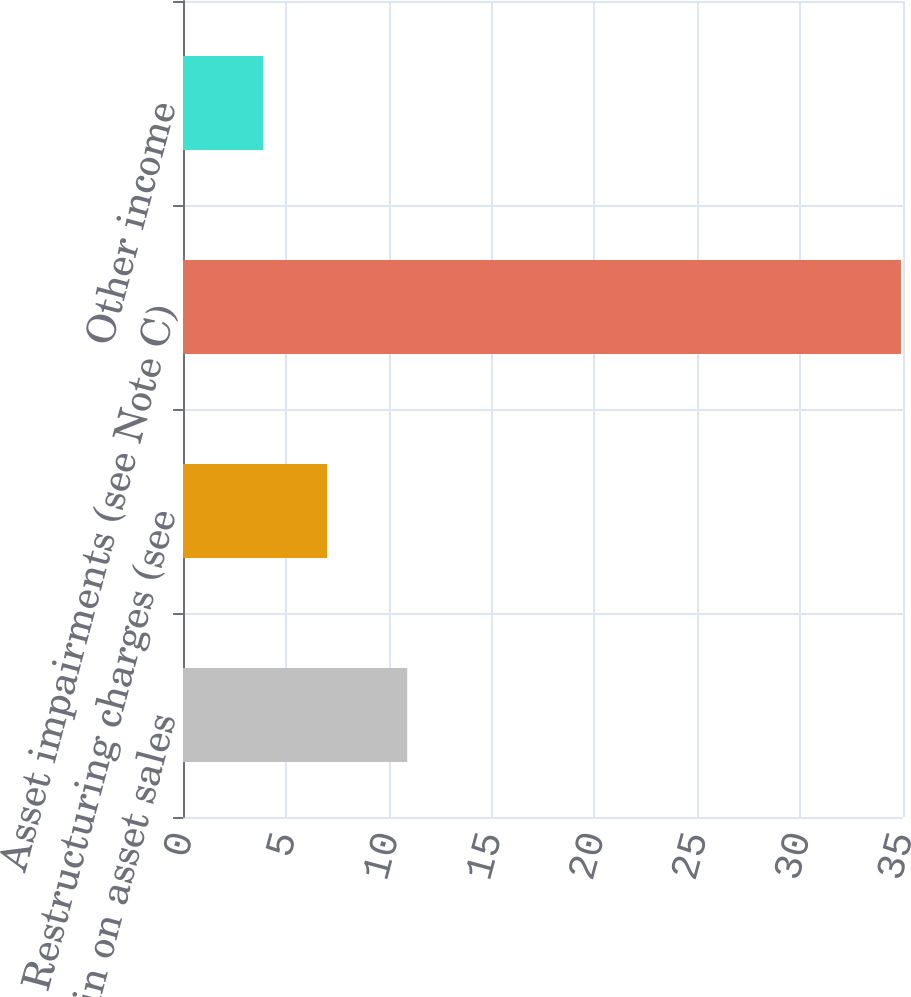<chart> <loc_0><loc_0><loc_500><loc_500><bar_chart><fcel>Gain on asset sales<fcel>Restructuring charges (see<fcel>Asset impairments (see Note C)<fcel>Other income<nl><fcel>10.9<fcel>7<fcel>34.9<fcel>3.9<nl></chart> 